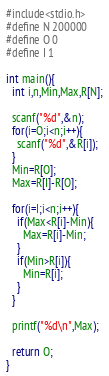<code> <loc_0><loc_0><loc_500><loc_500><_C_>#include<stdio.h>
#define N 200000
#define O 0
#define I 1

int main(){
  int i,n,Min,Max,R[N];

  scanf("%d",&n);
  for(i=O;i<n;i++){
    scanf("%d",&R[i]);
  }
  Min=R[O];
  Max=R[I]-R[O];

  for(i=I;i<n;i++){
    if(Max<R[i]-Min){
      Max=R[i]-Min;
    }
    if(Min>R[i]){
      Min=R[i];
    }
  }

  printf("%d\n",Max);

  return O;
}

</code> 